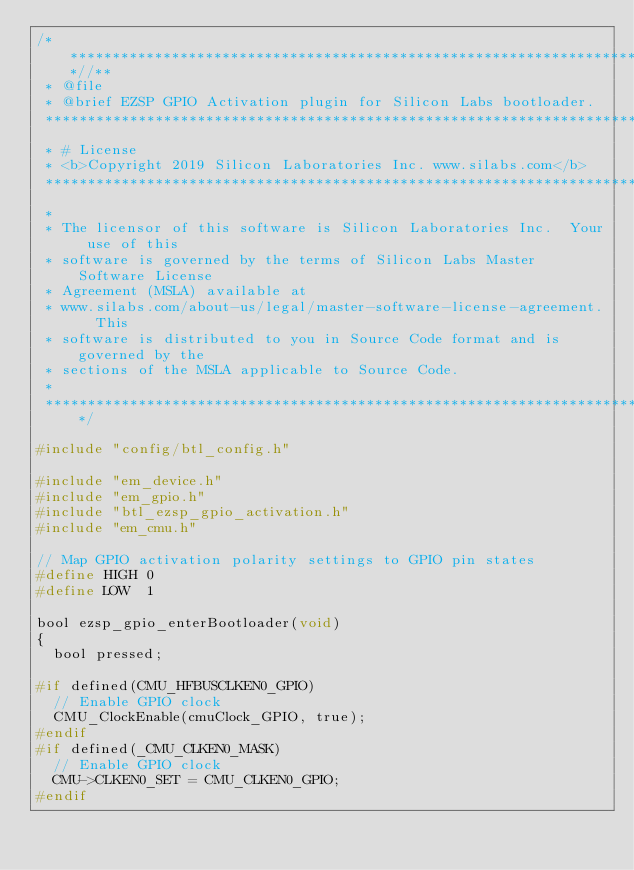Convert code to text. <code><loc_0><loc_0><loc_500><loc_500><_C_>/***************************************************************************//**
 * @file
 * @brief EZSP GPIO Activation plugin for Silicon Labs bootloader.
 *******************************************************************************
 * # License
 * <b>Copyright 2019 Silicon Laboratories Inc. www.silabs.com</b>
 *******************************************************************************
 *
 * The licensor of this software is Silicon Laboratories Inc.  Your use of this
 * software is governed by the terms of Silicon Labs Master Software License
 * Agreement (MSLA) available at
 * www.silabs.com/about-us/legal/master-software-license-agreement.  This
 * software is distributed to you in Source Code format and is governed by the
 * sections of the MSLA applicable to Source Code.
 *
 ******************************************************************************/

#include "config/btl_config.h"

#include "em_device.h"
#include "em_gpio.h"
#include "btl_ezsp_gpio_activation.h"
#include "em_cmu.h"

// Map GPIO activation polarity settings to GPIO pin states
#define HIGH 0
#define LOW  1

bool ezsp_gpio_enterBootloader(void)
{
  bool pressed;

#if defined(CMU_HFBUSCLKEN0_GPIO)
  // Enable GPIO clock
  CMU_ClockEnable(cmuClock_GPIO, true);
#endif
#if defined(_CMU_CLKEN0_MASK)
  // Enable GPIO clock
  CMU->CLKEN0_SET = CMU_CLKEN0_GPIO;
#endif
</code> 